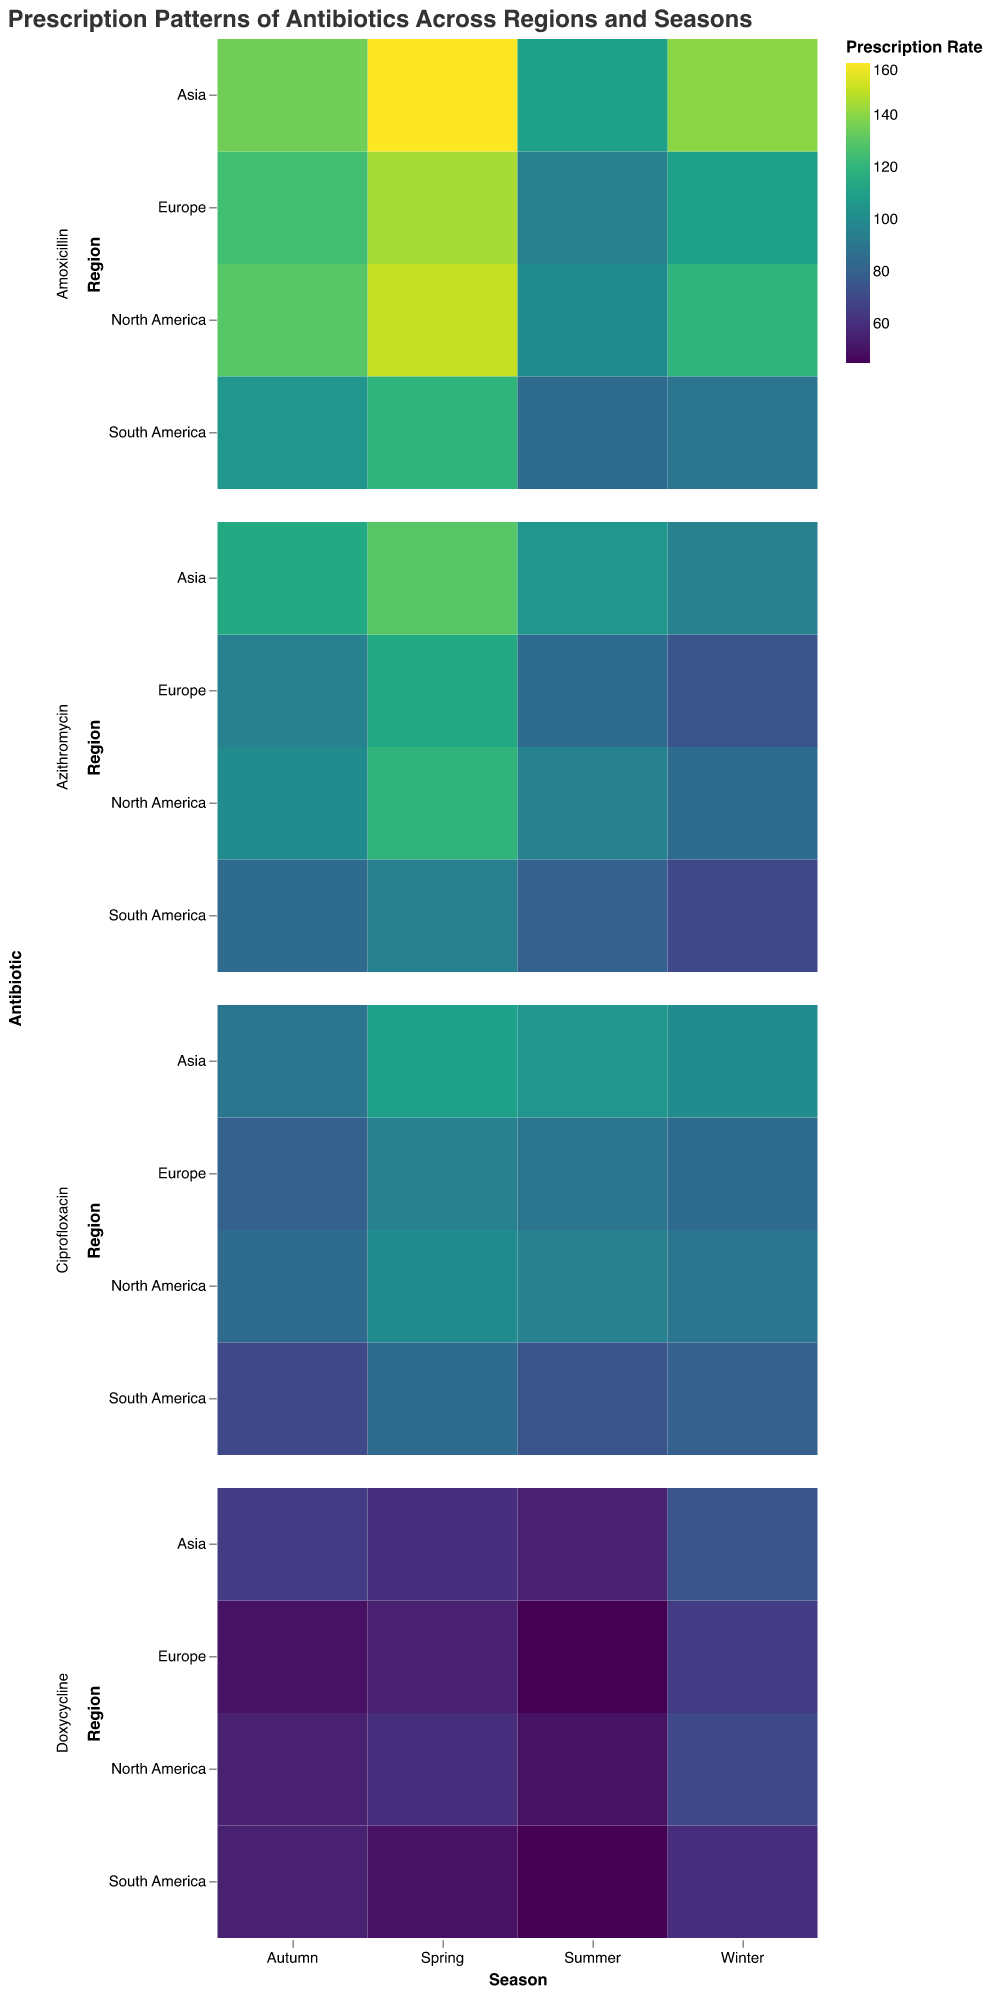Which season has the highest prescription rate for Amoxicillin in North America? Look at the "Amoxicillin" row for "North America" and find the cell with the highest color intensity or numerical value.
Answer: Spring In which region is the prescription of Doxycycline highest during Winter? Look at the "Winter" column in the "Doxycycline" row and find the region with the highest color intensity or numerical value.
Answer: Asia What is the difference in Amoxicillin prescriptions between Summer and Winter in Europe? Find the Amoxicillin values for Summer and Winter in Europe, then subtract the Winter value (110) from the Summer value (95). 110 - 95 = 15
Answer: 15 Compare the prescription rates of Azithromycin and Ciprofloxacin in Asia during Spring. Which is higher? Compare the numerical values of Azithromycin and Ciprofloxacin for Spring in Asia. Azithromycin is 130 and Ciprofloxacin is 110, so Azithromycin is higher.
Answer: Azithromycin Which region has the least variation in Ciprofloxacin prescriptions across all seasons? Calculate the difference between the highest and lowest values of Ciprofloxacin for each region and compare. The smallest range is in North America (100 - 85 = 15), Europe (95 - 80 = 15), Asia (110 - 90 = 20), South America (85 - 70 = 15). They all have equal minimum variation of 15, so no single least varied region.
Answer: North America, Europe, South America What is the average prescription rate of Amoxicillin in Asia? Add up the values of Amoxicillin in Asia over all seasons (140 + 160 + 110 + 135) and then divide by 4. (140 + 160 + 110 + 135) / 4 = 135
Answer: 135 During which season is Doxycycline least prescribed in South America? Look at the "Doxycycline" row for "South America" and find the cell with the lowest color intensity or numerical value.
Answer: Summer Which antibiotic shows the highest prescription rate in any region and season? Find the cell with the maximum color intensity or numerical value across all antibiotics, regions, and seasons. The highest value is 160 for Amoxicillin in Asia during Spring.
Answer: Amoxicillin in Asia during Spring Is there any region where the prescription rate of Ciprofloxacin is greater than Doxycycline in all seasons? Compare the values of Ciprofloxacin and Doxycycline for each season in each region. North America Ciprofloxacin higher in Winter (Ciprofloxacin 90, Doxycycline 70), in Spring (Ciprofloxacin 100, Doxycycline 60), in Summer (Ciprofloxacin 95, Doxycycline 50), and in Autumn (Ciprofloxacin 85, Doxycycline 55).
Answer: North America 